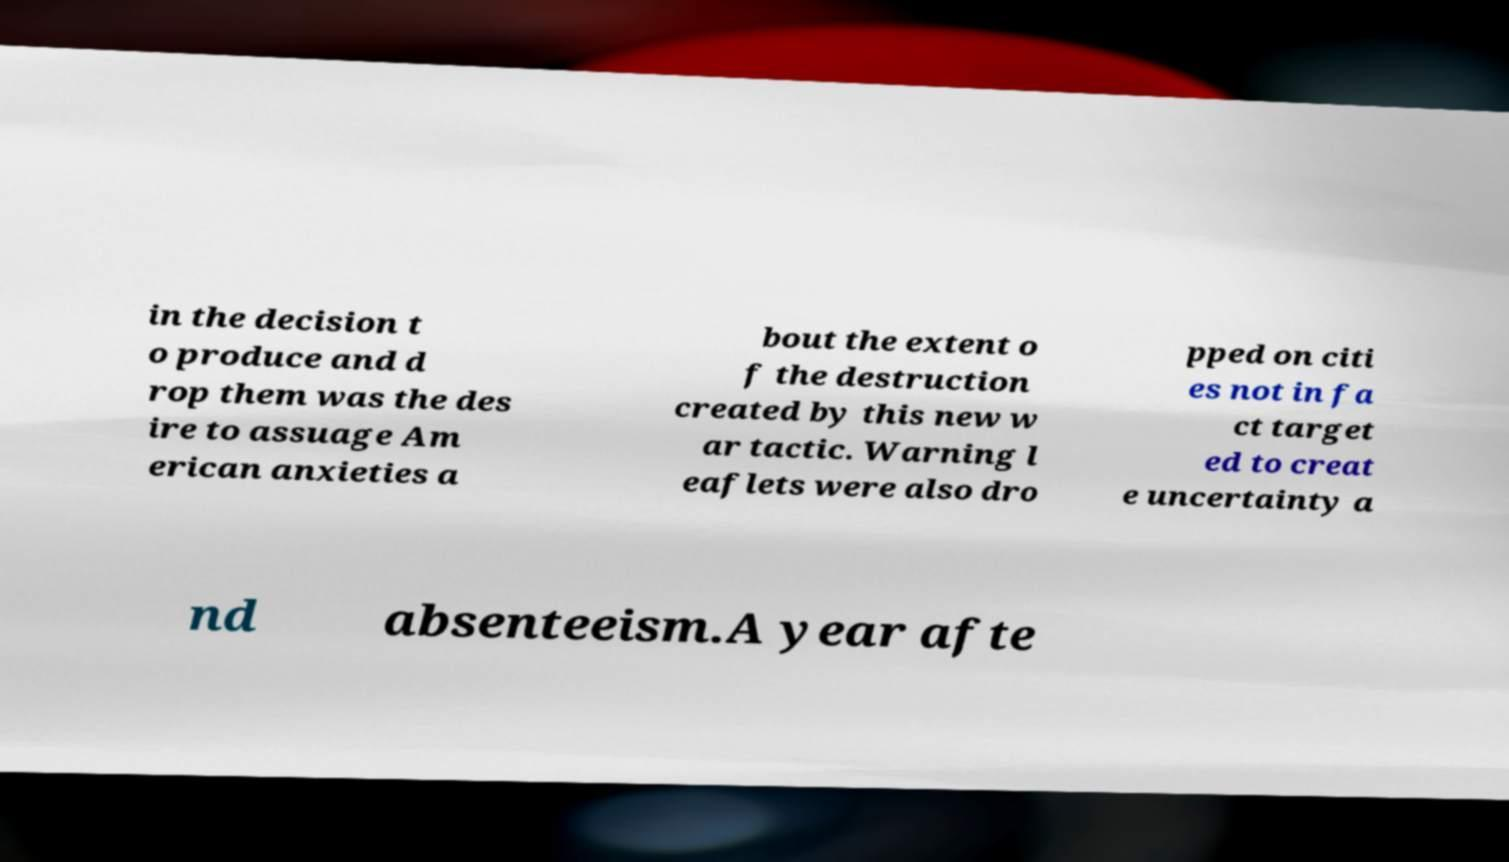There's text embedded in this image that I need extracted. Can you transcribe it verbatim? in the decision t o produce and d rop them was the des ire to assuage Am erican anxieties a bout the extent o f the destruction created by this new w ar tactic. Warning l eaflets were also dro pped on citi es not in fa ct target ed to creat e uncertainty a nd absenteeism.A year afte 